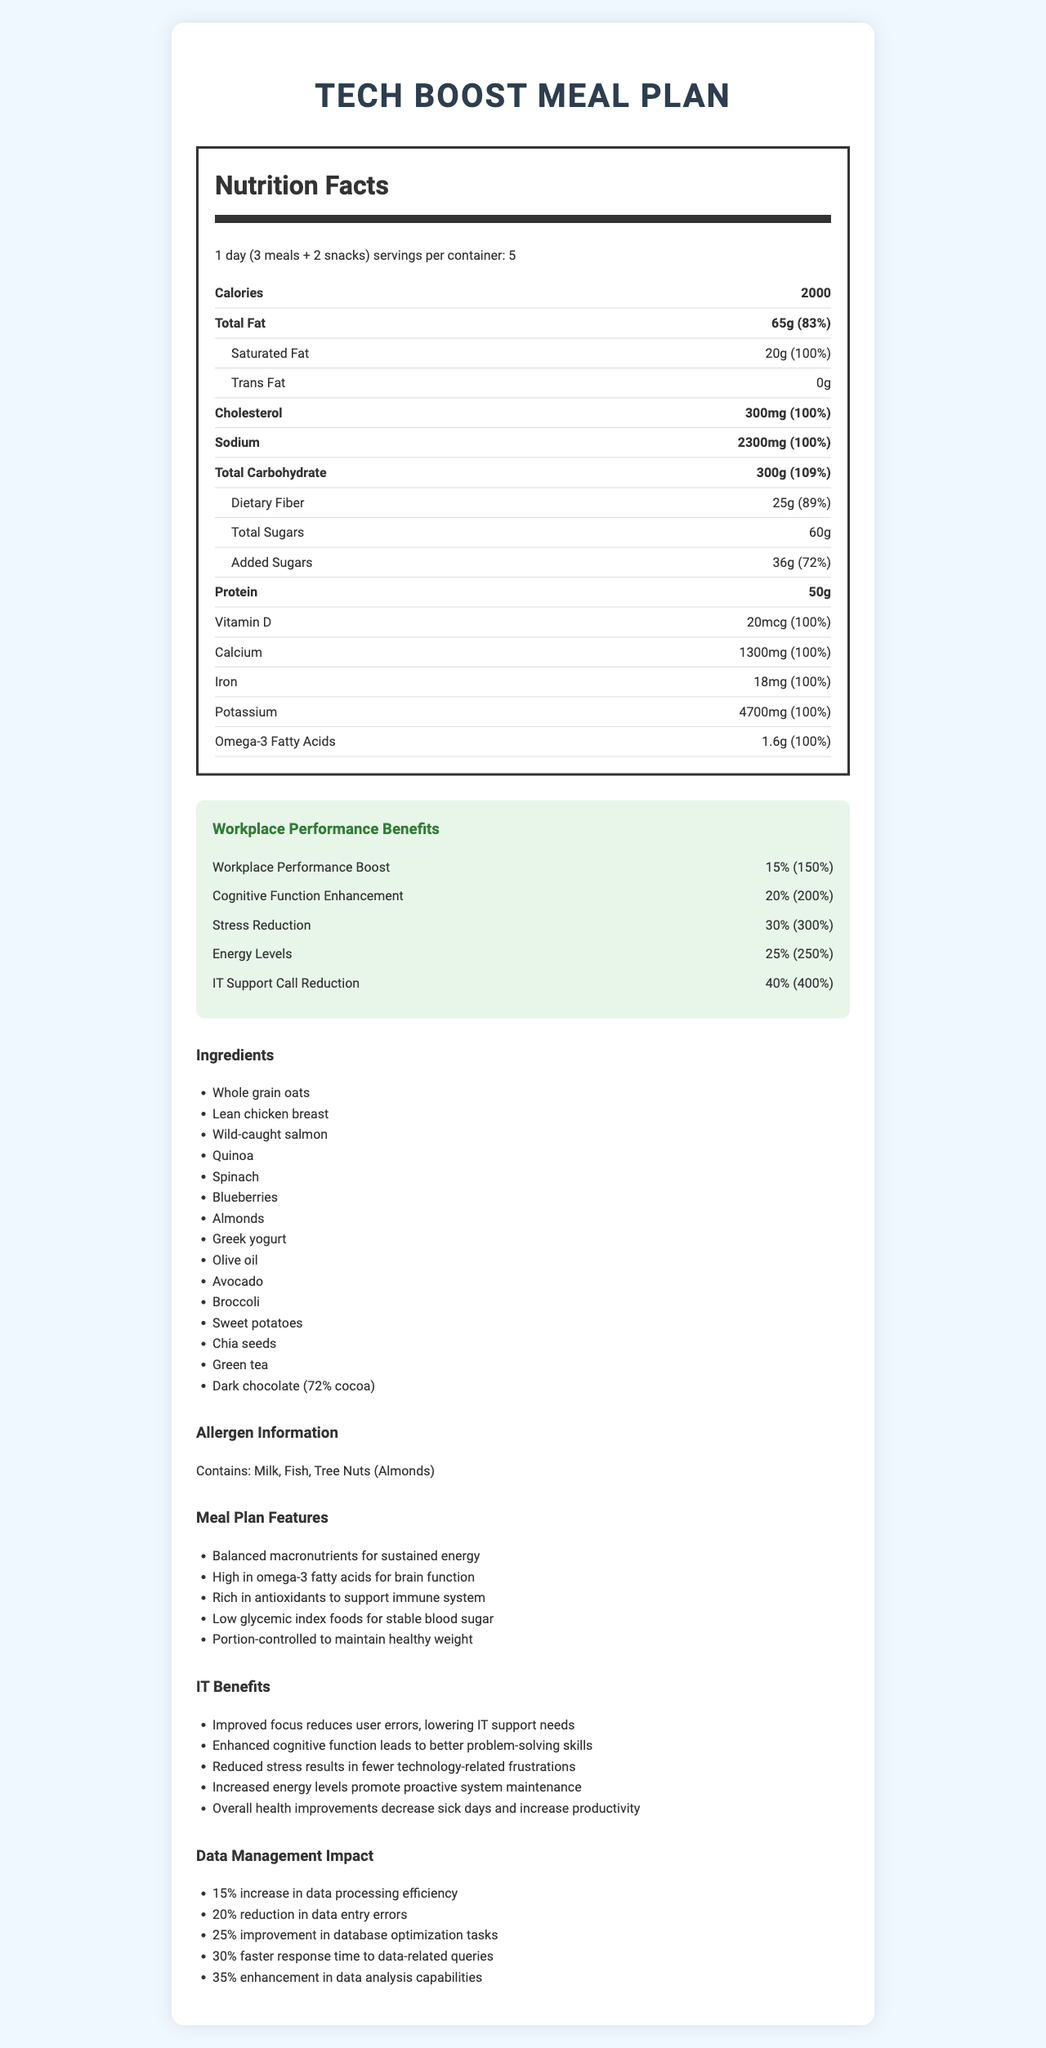what is the product name of the meal plan? The product name is clearly stated at the beginning of the document.
Answer: Tech Boost Meal Plan how many calories does one serving contain? The document lists that each serving contains 2000 calories under the nutrition facts section.
Answer: 2000 what is the serving size for this meal plan? This information is given under the nutrition facts label, next to serving size.
Answer: 1 day (3 meals + 2 snacks) how much omega-3 fatty acids are in one serving? The amount of omega-3 fatty acids is listed in the nutrition facts under Omega-3 Fatty Acids.
Answer: 1.6g what are the main ingredients of this meal plan? The ingredients list can be found in the section titled "Ingredients".
Answer: Whole grain oats, Lean chicken breast, Wild-caught salmon, Quinoa, Spinach, Blueberries, Almonds, Greek yogurt, Olive oil, Avocado, Broccoli, Sweet potatoes, Chia seeds, Green tea, Dark chocolate (72% cocoa) which of these is NOT an ingredient in the meal plan? A. Tomato B. Spinach C. Blueberries D. Quinoa Tomato is not listed as an ingredient in the meal plan, while Spinach, Blueberries, and Quinoa are included.
Answer: A how many servings are there per container? This information is stated under the nutrition facts section, where it specifies servings per container.
Answer: 5 does the meal plan contain any allergens? Yes/No The allergen information is provided and states the meal plan contains milk, fish, and tree nuts (almonds).
Answer: Yes what is the percentage of daily value for calcium in one serving? The document lists the daily value percentage for calcium as 100%.
Answer: 100% how much total fat is in one serving and what percent of the daily value does this represent? The amount and daily value percentage for total fat are listed under the nutrition facts.
Answer: 65g and 83% what are some of the IT benefits provided by this meal plan? These IT benefits are specified in the section titled "IT Benefits".
Answer: Improved focus reduces user errors, Enhanced cognitive function, Reduced stress, Increased energy levels, Decreased sick days summarize the main features and benefits of the Tech Boost Meal Plan. The document outlines the nutritional content, ingredients, workplace and IT benefits, making it clear that this meal plan is designed to enhance both physical health and work performance.
Answer: The Tech Boost Meal Plan offers balanced nutrition tailored to improve workplace performance and overall employee wellness. It includes ingredients that support energy, brain function, and immune health. This meal plan is designed to benefit IT operations by improving focus, cognitive function, and reducing stress and sick days, ultimately leading to increased productivity and fewer IT support needs. what impact does the Tech Boost Meal Plan have on data management? The specific data management impacts are listed under the section titled "Data Management Impact".
Answer: 15% increase in data processing efficiency, 20% reduction in data entry errors, 25% improvement in database optimization tasks, 30% faster response time to data-related queries, 35% enhancement in data analysis capabilities how much protein is included in one serving of the meal plan? The protein content is listed under the nutrition facts section.
Answer: 50g what is the trans fat content in each serving? The nutrition facts section lists the trans fat content as 0g.
Answer: 0g how does the meal plan contribute to workplace performance? A. Improved focus B. Enhanced cognitive function C. Reduced stress D. All of the above All these benefits are listed under "Workplace Performance Benefits".
Answer: D what is the source of the salmon in the meal plan? The ingredient list specifies "Wild-caught salmon".
Answer: Wild-caught who manufactures the Tech Boost Meal Plan? The document does not provide information about the manufacturer of the meal plan.
Answer: Not enough information 